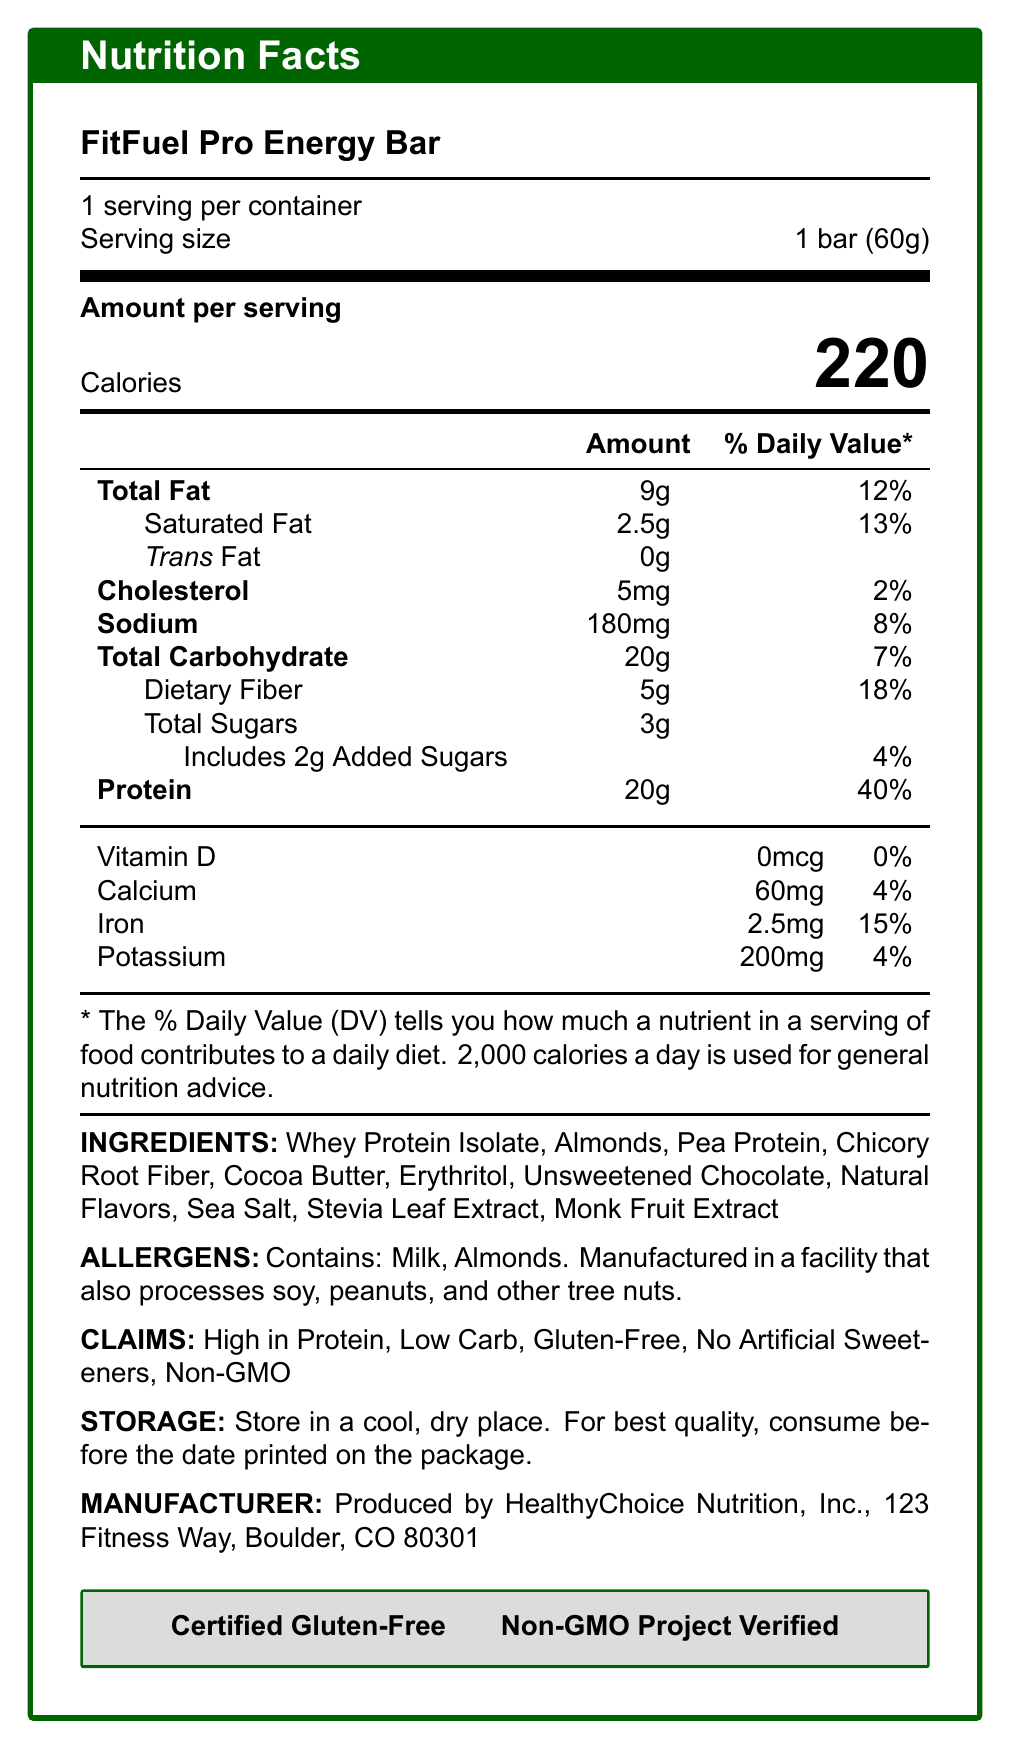What is the serving size of the FitFuel Pro Energy Bar? The serving size is listed as "1 bar (60g)" in the document.
Answer: 1 bar (60g) How many calories are in one serving of the FitFuel Pro Energy Bar? The document states that the amount of calories per serving is 220.
Answer: 220 What percentage of the Daily Value is the protein content in the FitFuel Pro Energy Bar? The percentage Daily Value for protein is listed as 40% in the document.
Answer: 40% What ingredients are used in the FitFuel Pro Energy Bar? The document lists these ingredients under the "INGREDIENTS" section.
Answer: Whey Protein Isolate, Almonds, Pea Protein, Chicory Root Fiber, Cocoa Butter, Erythritol, Unsweetened Chocolate, Natural Flavors, Sea Salt, Stevia Leaf Extract, Monk Fruit Extract Which allergens are present in the FitFuel Pro Energy Bar? The document states that the bar contains milk and almonds.
Answer: Milk, Almonds Which of the following certifications does the FitFuel Pro Energy Bar have? A. USDA Organic B. Kosher Certified C. Certified Gluten-Free D. Fair Trade Certified The bar is certified gluten-free as indicated in the document.
Answer: C What is the total fat content in one serving of the FitFuel Pro Energy Bar? A. 5g B. 9g C. 13g D. 18g The total fat content is listed as 9g in the document.
Answer: B Is the FitFuel Pro Energy Bar gluten-free? The document claims that the bar is gluten-free under the "CLAIMS" section.
Answer: Yes Does the FitFuel Pro Energy Bar contain any artificial sweeteners? The document specifically claims "No Artificial Sweeteners" under the "CLAIMS" section.
Answer: No Summarize the key nutritional aspects of the FitFuel Pro Energy Bar. This summary captures all the main nutritional details, claims, and certifications of the FitFuel Pro Energy Bar as laid out in the document.
Answer: The FitFuel Pro Energy Bar is high in protein (20g, 40% DV) and low in carbohydrates (20g, 7% DV), with 220 calories per serving. It contains 9g of total fat (12% DV), including 2.5g of saturated fat. The bar also provides dietary fiber (5g, 18% DV) and has minimal sugars (3g total, 2g added). It is certified gluten-free and non-GMO, and includes ingredients like whey protein isolate, almonds, and pea protein. Does the FitFuel Pro Energy Bar provide any Vitamin D? The document lists Vitamin D as 0mcg, 0% Daily Value.
Answer: No Where is the FitFuel Pro Energy Bar manufactured? The manufacturer's information is given at the bottom of the document.
Answer: HealthyChoice Nutrition, Inc., 123 Fitness Way, Boulder, CO 80301 What should you do if you are allergic to peanuts? The document states that the bar is manufactured in a facility that also processes peanuts, but it does not provide specific advice for individuals with peanut allergies.
Answer: Not enough information 